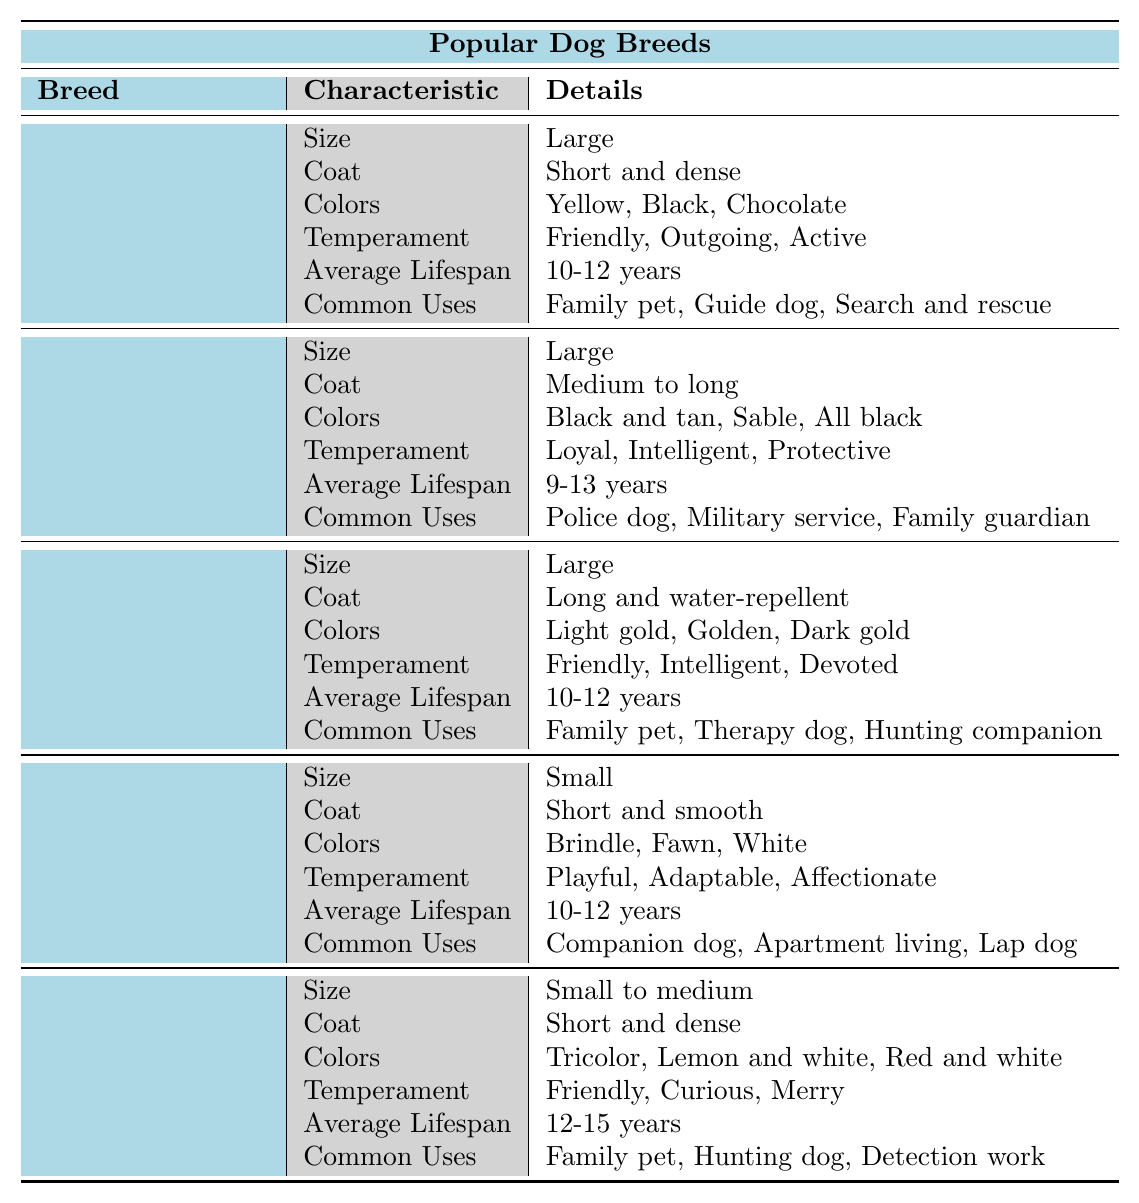What is the average lifespan of a Beagle? According to the table, the average lifespan for a Beagle is provided directly. The average lifespan is listed as 12-15 years.
Answer: 12-15 years Which dog breed is known for being a family guardian? The table lists the German Shepherd under the column for common uses, indicating it is a family guardian along with other roles.
Answer: German Shepherd How many colors are listed for the Labrador Retriever? The Labrador Retriever has three colors listed: Yellow, Black, and Chocolate. Counting these gives us a total of three.
Answer: 3 Is the French Bulldog considered a large breed? The table specifies that the French Bulldog's size is "Small," which indicates that it is not considered a large breed.
Answer: No What are the common uses of the Golden Retriever? The common uses for the Golden Retriever are listed as Family pet, Therapy dog, and Hunting companion. These can be found in the respective section of the table.
Answer: Family pet, Therapy dog, Hunting companion What breed has a medium to long coat and a lifespan of 9-13 years? Referring to the table, the breed with a medium to long coat is the German Shepherd, and its average lifespan is listed as 9-13 years.
Answer: German Shepherd Which dog breeds have an average lifespan of 10-12 years? Looking through the table, the breeds that have an average lifespan of 10-12 years are the Labrador Retriever, Golden Retriever, and French Bulldog.
Answer: Labrador Retriever, Golden Retriever, French Bulldog What is the temperament of the Beagle? The temperament of the Beagle is listed as Friendly, Curious, and Merry in the corresponding section of the table.
Answer: Friendly, Curious, Merry If you combine the common uses of the Labrador Retriever and the Golden Retriever, how many unique uses do you get? The Labrador Retriever has three common uses (Family pet, Guide dog, Search and rescue), and the Golden Retriever has three (Family pet, Therapy dog, Hunting companion). The common use "Family pet" is repeated, so we combine them: Guide dog, Search and rescue, Therapy dog, and Hunting companion, resulting in five unique uses.
Answer: 5 Which breed has the shortest average lifespan, and what is that lifespan? The Beagle has the shortest average lifespan listed in the table as 12-15 years, while other breeds have equal or longer lifespans. This requires comparing the average lifespans from each breed.
Answer: Beagle, 12-15 years 